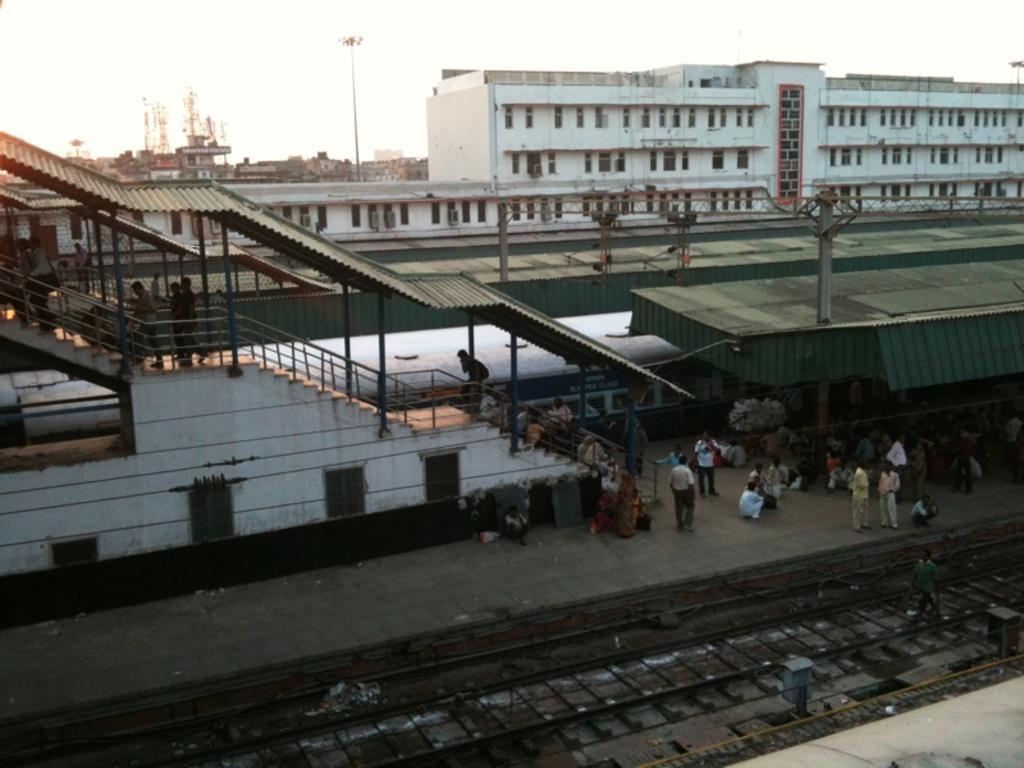In one or two sentences, can you explain what this image depicts? This is an outside view. At the bottom there is a railway track and there are many people on the platform. On the left side there are stairs, behind there is a train. In the background there are few buildings. At the top of the image I can see the sky. On the stairs there are few people walking. 